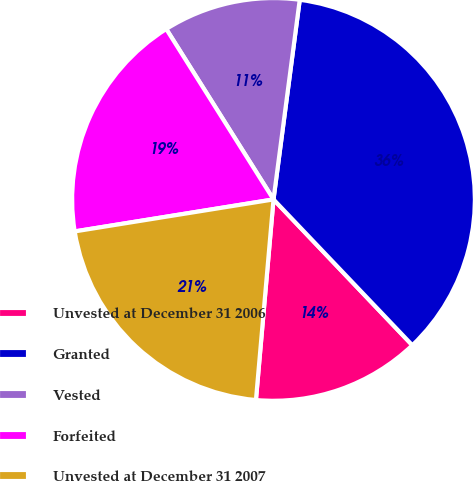Convert chart. <chart><loc_0><loc_0><loc_500><loc_500><pie_chart><fcel>Unvested at December 31 2006<fcel>Granted<fcel>Vested<fcel>Forfeited<fcel>Unvested at December 31 2007<nl><fcel>13.5%<fcel>35.81%<fcel>11.02%<fcel>18.6%<fcel>21.07%<nl></chart> 